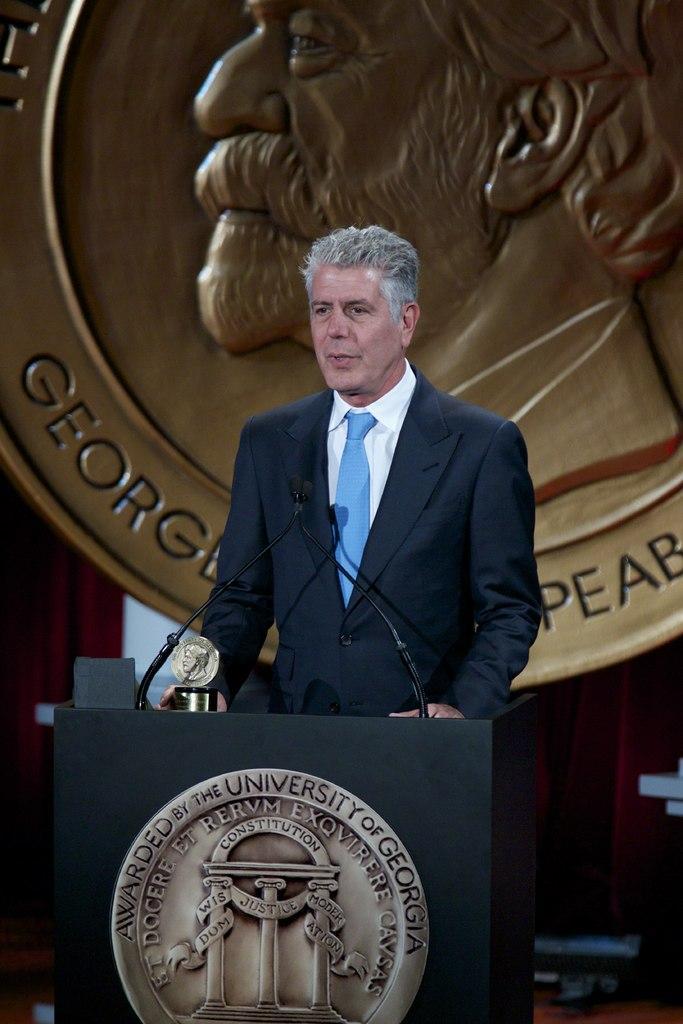Describe this image in one or two sentences. In this picture we can see man wearing black color coat with blue tie standing at the speech desk and delivering the speech in the microphone. Behind we can see golden color round disc on which "George" is written. 